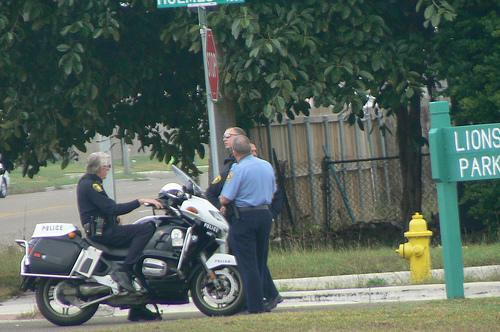Question: what type of traffic sign is above the people?
Choices:
A. Yield.
B. Stop.
C. Slow.
D. One way.
Answer with the letter. Answer: B Question: what is the occupation of the people shown?
Choices:
A. Police Officer.
B. Doctors.
C. Lawyers.
D. Butchers.
Answer with the letter. Answer: A Question: what is the name of the park?
Choices:
A. Central park.
B. Memorial park.
C. Lions park.
D. City park.
Answer with the letter. Answer: C Question: how many people are at least partially visible?
Choices:
A. Four.
B. Two.
C. One.
D. Six.
Answer with the letter. Answer: A 